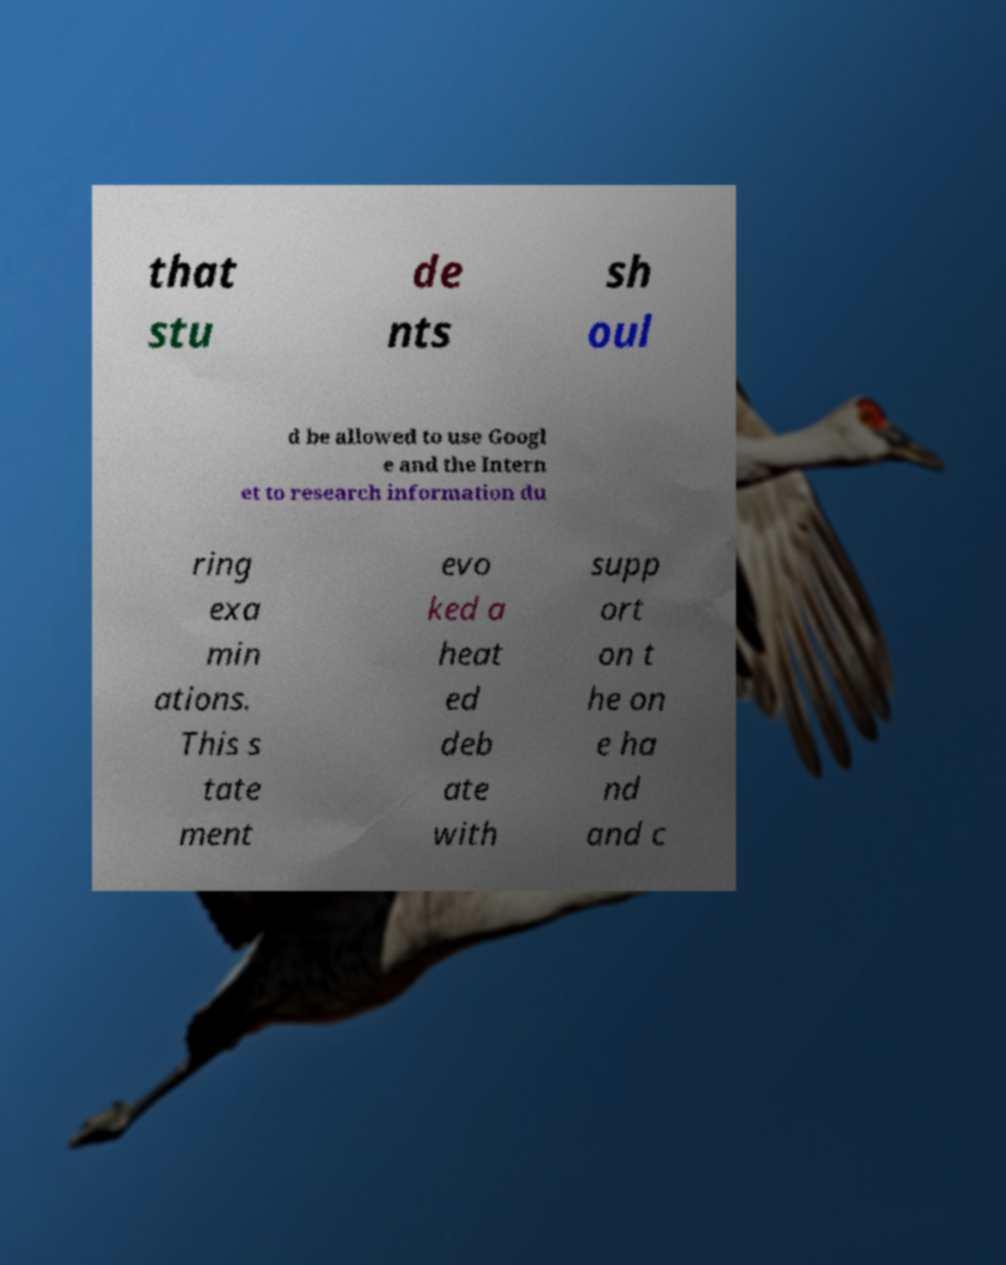Can you read and provide the text displayed in the image?This photo seems to have some interesting text. Can you extract and type it out for me? that stu de nts sh oul d be allowed to use Googl e and the Intern et to research information du ring exa min ations. This s tate ment evo ked a heat ed deb ate with supp ort on t he on e ha nd and c 